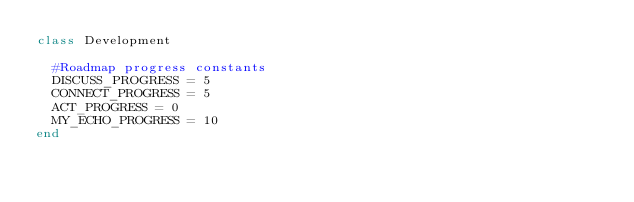<code> <loc_0><loc_0><loc_500><loc_500><_Ruby_>class Development

  #Roadmap progress constants
  DISCUSS_PROGRESS = 5
  CONNECT_PROGRESS = 5
  ACT_PROGRESS = 0
  MY_ECHO_PROGRESS = 10
end</code> 